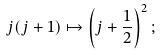<formula> <loc_0><loc_0><loc_500><loc_500>j ( j + 1 ) \mapsto \left ( j + \frac { 1 } { 2 } \right ) ^ { 2 } ;</formula> 